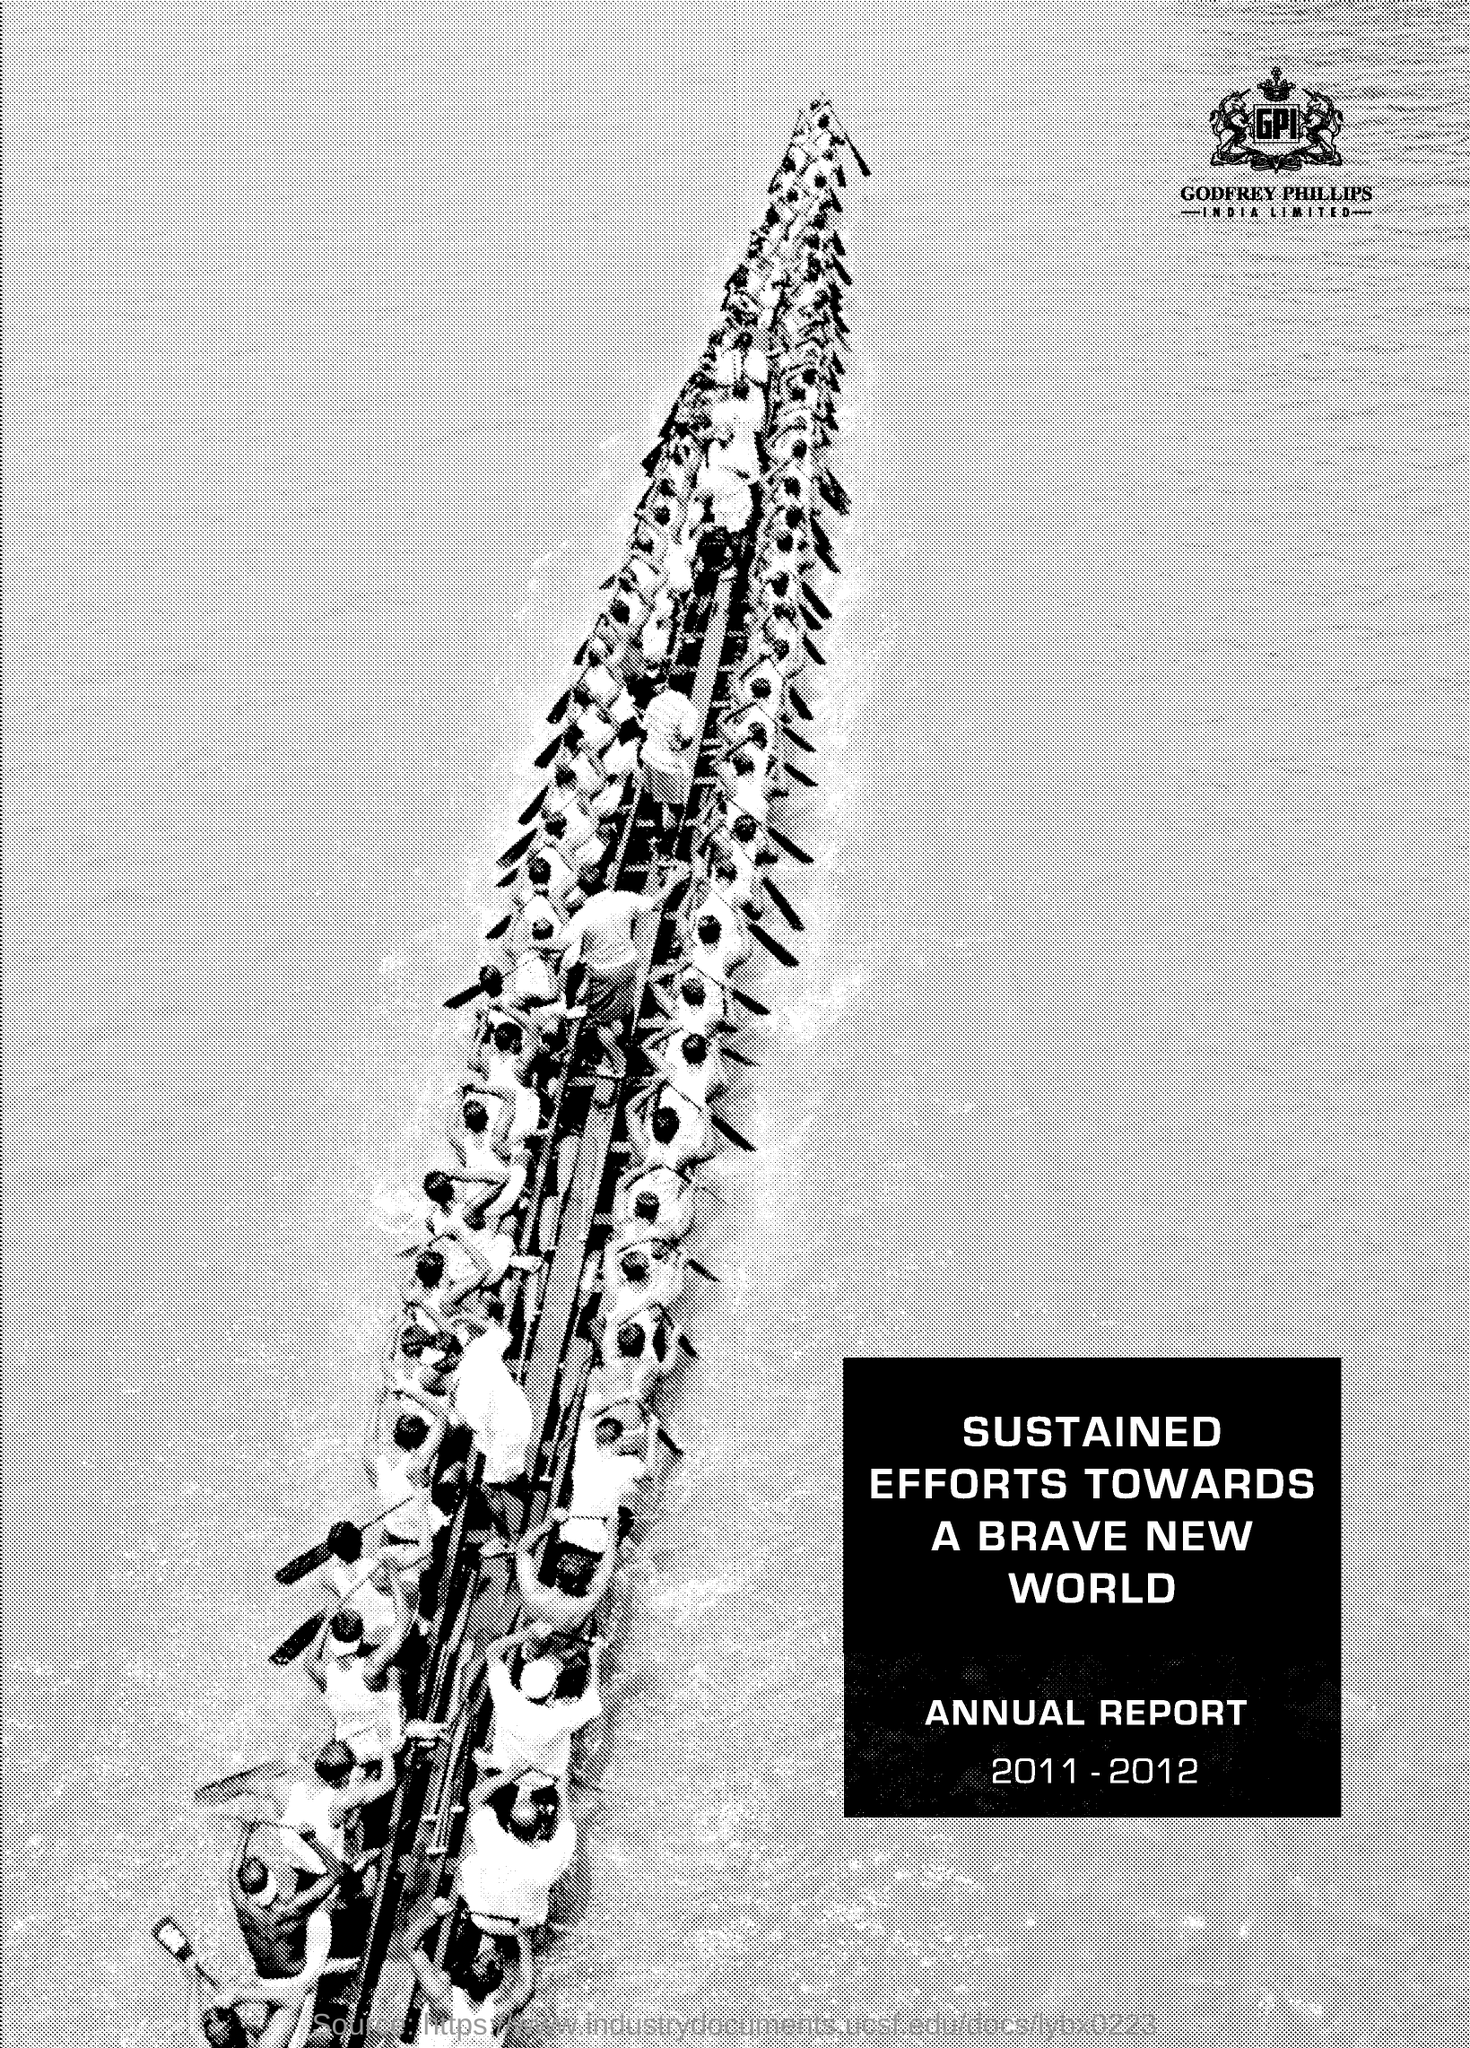Indicate a few pertinent items in this graphic. Godfrey Phillips India Limited is mentioned in the document. The annual report mentions the years 2011-2012. 